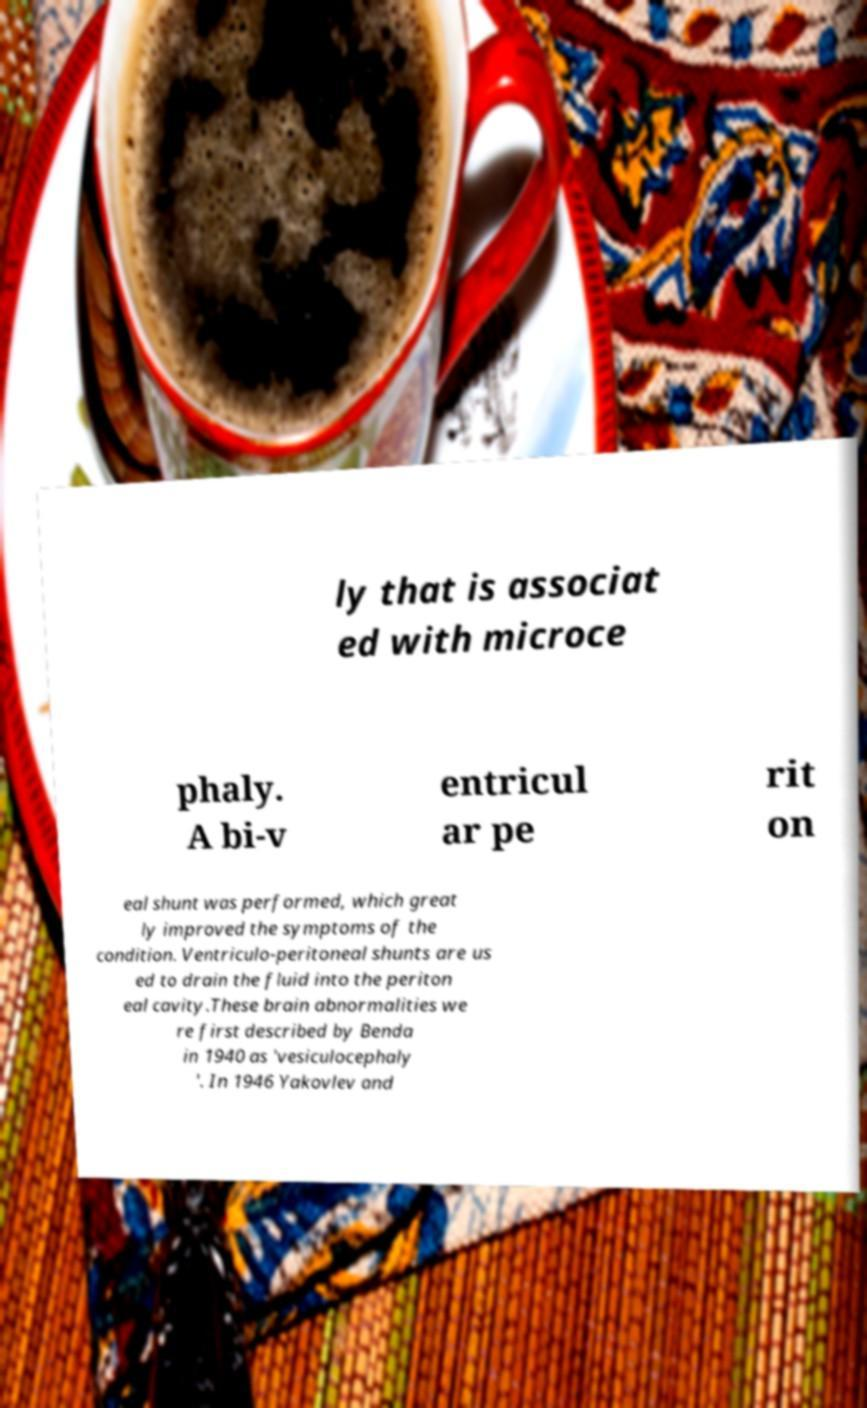Can you accurately transcribe the text from the provided image for me? ly that is associat ed with microce phaly. A bi-v entricul ar pe rit on eal shunt was performed, which great ly improved the symptoms of the condition. Ventriculo-peritoneal shunts are us ed to drain the fluid into the periton eal cavity.These brain abnormalities we re first described by Benda in 1940 as 'vesiculocephaly '. In 1946 Yakovlev and 